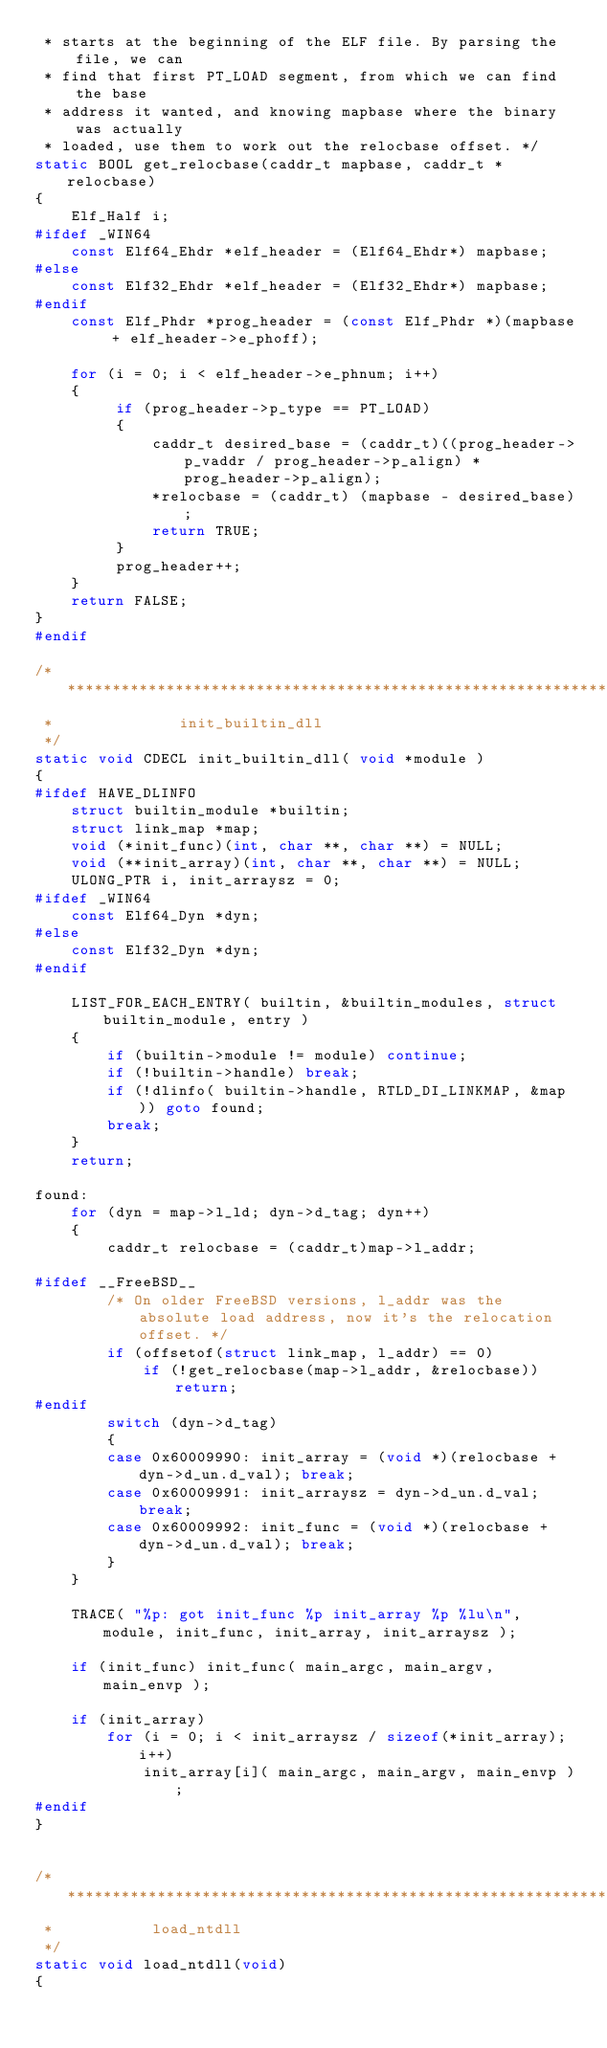<code> <loc_0><loc_0><loc_500><loc_500><_C_> * starts at the beginning of the ELF file. By parsing the file, we can
 * find that first PT_LOAD segment, from which we can find the base
 * address it wanted, and knowing mapbase where the binary was actually
 * loaded, use them to work out the relocbase offset. */
static BOOL get_relocbase(caddr_t mapbase, caddr_t *relocbase)
{
    Elf_Half i;
#ifdef _WIN64
    const Elf64_Ehdr *elf_header = (Elf64_Ehdr*) mapbase;
#else
    const Elf32_Ehdr *elf_header = (Elf32_Ehdr*) mapbase;
#endif
    const Elf_Phdr *prog_header = (const Elf_Phdr *)(mapbase + elf_header->e_phoff);

    for (i = 0; i < elf_header->e_phnum; i++)
    {
         if (prog_header->p_type == PT_LOAD)
         {
             caddr_t desired_base = (caddr_t)((prog_header->p_vaddr / prog_header->p_align) * prog_header->p_align);
             *relocbase = (caddr_t) (mapbase - desired_base);
             return TRUE;
         }
         prog_header++;
    }
    return FALSE;
}
#endif

/*************************************************************************
 *              init_builtin_dll
 */
static void CDECL init_builtin_dll( void *module )
{
#ifdef HAVE_DLINFO
    struct builtin_module *builtin;
    struct link_map *map;
    void (*init_func)(int, char **, char **) = NULL;
    void (**init_array)(int, char **, char **) = NULL;
    ULONG_PTR i, init_arraysz = 0;
#ifdef _WIN64
    const Elf64_Dyn *dyn;
#else
    const Elf32_Dyn *dyn;
#endif

    LIST_FOR_EACH_ENTRY( builtin, &builtin_modules, struct builtin_module, entry )
    {
        if (builtin->module != module) continue;
        if (!builtin->handle) break;
        if (!dlinfo( builtin->handle, RTLD_DI_LINKMAP, &map )) goto found;
        break;
    }
    return;

found:
    for (dyn = map->l_ld; dyn->d_tag; dyn++)
    {
        caddr_t relocbase = (caddr_t)map->l_addr;

#ifdef __FreeBSD__
        /* On older FreeBSD versions, l_addr was the absolute load address, now it's the relocation offset. */
        if (offsetof(struct link_map, l_addr) == 0)
            if (!get_relocbase(map->l_addr, &relocbase)) return;
#endif
        switch (dyn->d_tag)
        {
        case 0x60009990: init_array = (void *)(relocbase + dyn->d_un.d_val); break;
        case 0x60009991: init_arraysz = dyn->d_un.d_val; break;
        case 0x60009992: init_func = (void *)(relocbase + dyn->d_un.d_val); break;
        }
    }

    TRACE( "%p: got init_func %p init_array %p %lu\n", module, init_func, init_array, init_arraysz );

    if (init_func) init_func( main_argc, main_argv, main_envp );

    if (init_array)
        for (i = 0; i < init_arraysz / sizeof(*init_array); i++)
            init_array[i]( main_argc, main_argv, main_envp );
#endif
}


/***********************************************************************
 *           load_ntdll
 */
static void load_ntdll(void)
{</code> 